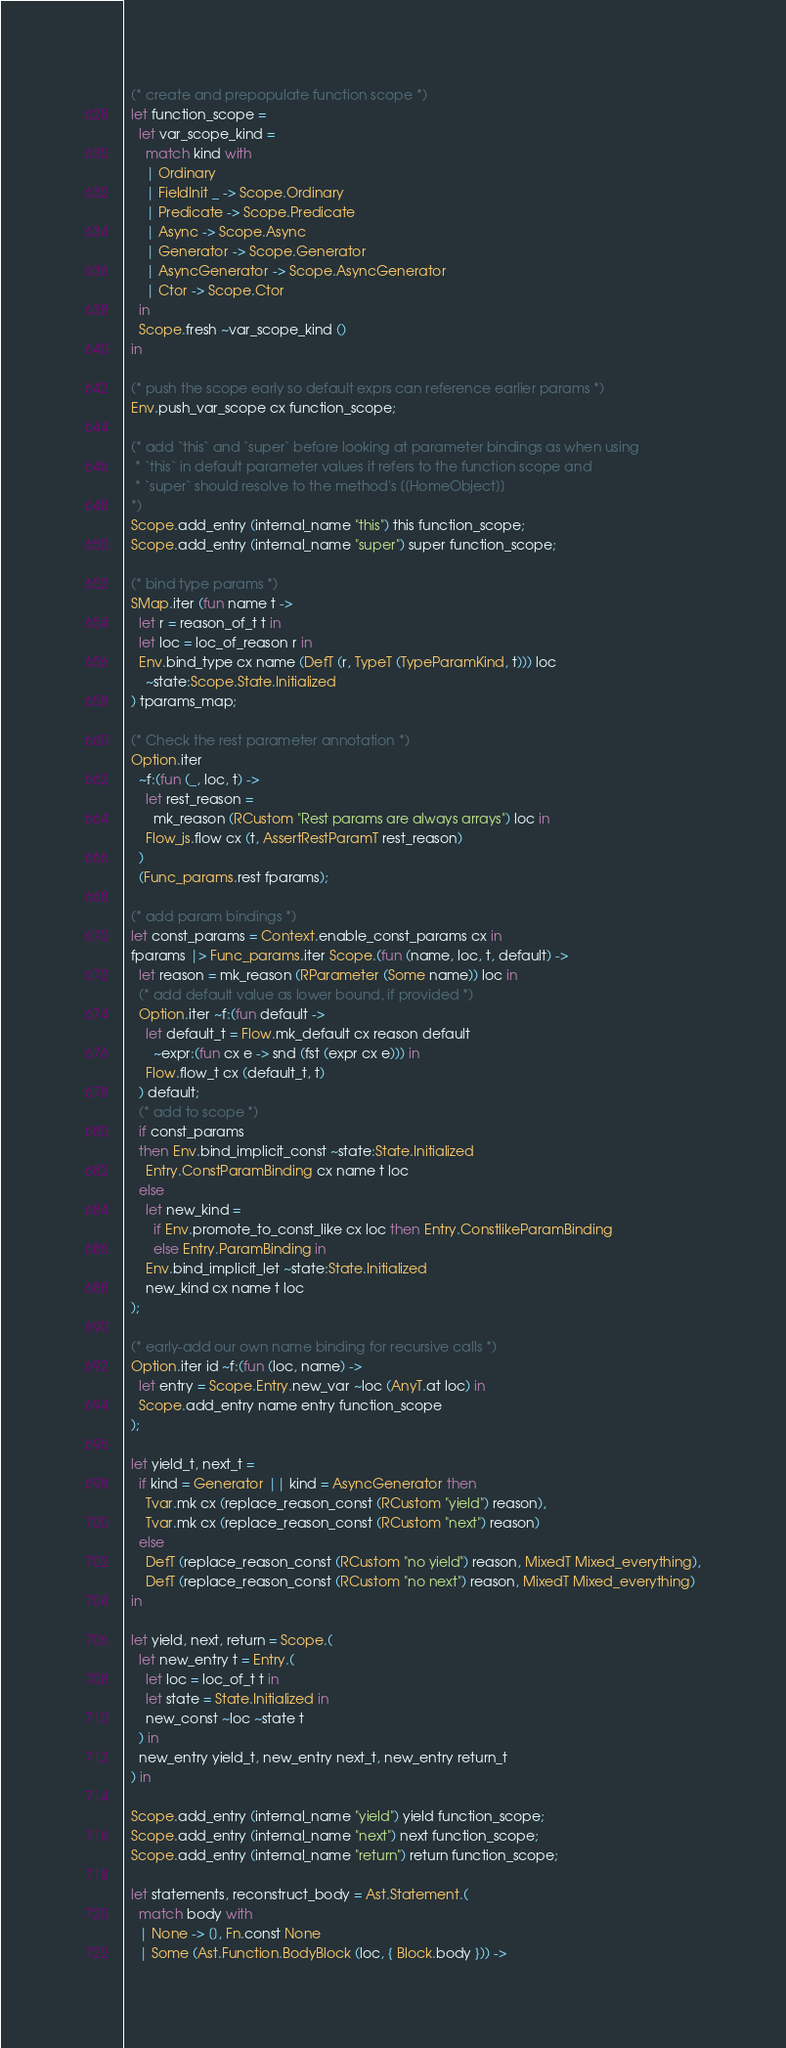<code> <loc_0><loc_0><loc_500><loc_500><_OCaml_>  (* create and prepopulate function scope *)
  let function_scope =
    let var_scope_kind =
      match kind with
      | Ordinary
      | FieldInit _ -> Scope.Ordinary
      | Predicate -> Scope.Predicate
      | Async -> Scope.Async
      | Generator -> Scope.Generator
      | AsyncGenerator -> Scope.AsyncGenerator
      | Ctor -> Scope.Ctor
    in
    Scope.fresh ~var_scope_kind ()
  in

  (* push the scope early so default exprs can reference earlier params *)
  Env.push_var_scope cx function_scope;

  (* add `this` and `super` before looking at parameter bindings as when using
   * `this` in default parameter values it refers to the function scope and
   * `super` should resolve to the method's [[HomeObject]]
  *)
  Scope.add_entry (internal_name "this") this function_scope;
  Scope.add_entry (internal_name "super") super function_scope;

  (* bind type params *)
  SMap.iter (fun name t ->
    let r = reason_of_t t in
    let loc = loc_of_reason r in
    Env.bind_type cx name (DefT (r, TypeT (TypeParamKind, t))) loc
      ~state:Scope.State.Initialized
  ) tparams_map;

  (* Check the rest parameter annotation *)
  Option.iter
    ~f:(fun (_, loc, t) ->
      let rest_reason =
        mk_reason (RCustom "Rest params are always arrays") loc in
      Flow_js.flow cx (t, AssertRestParamT rest_reason)
    )
    (Func_params.rest fparams);

  (* add param bindings *)
  let const_params = Context.enable_const_params cx in
  fparams |> Func_params.iter Scope.(fun (name, loc, t, default) ->
    let reason = mk_reason (RParameter (Some name)) loc in
    (* add default value as lower bound, if provided *)
    Option.iter ~f:(fun default ->
      let default_t = Flow.mk_default cx reason default
        ~expr:(fun cx e -> snd (fst (expr cx e))) in
      Flow.flow_t cx (default_t, t)
    ) default;
    (* add to scope *)
    if const_params
    then Env.bind_implicit_const ~state:State.Initialized
      Entry.ConstParamBinding cx name t loc
    else
      let new_kind =
        if Env.promote_to_const_like cx loc then Entry.ConstlikeParamBinding
        else Entry.ParamBinding in
      Env.bind_implicit_let ~state:State.Initialized
      new_kind cx name t loc
  );

  (* early-add our own name binding for recursive calls *)
  Option.iter id ~f:(fun (loc, name) ->
    let entry = Scope.Entry.new_var ~loc (AnyT.at loc) in
    Scope.add_entry name entry function_scope
  );

  let yield_t, next_t =
    if kind = Generator || kind = AsyncGenerator then
      Tvar.mk cx (replace_reason_const (RCustom "yield") reason),
      Tvar.mk cx (replace_reason_const (RCustom "next") reason)
    else
      DefT (replace_reason_const (RCustom "no yield") reason, MixedT Mixed_everything),
      DefT (replace_reason_const (RCustom "no next") reason, MixedT Mixed_everything)
  in

  let yield, next, return = Scope.(
    let new_entry t = Entry.(
      let loc = loc_of_t t in
      let state = State.Initialized in
      new_const ~loc ~state t
    ) in
    new_entry yield_t, new_entry next_t, new_entry return_t
  ) in

  Scope.add_entry (internal_name "yield") yield function_scope;
  Scope.add_entry (internal_name "next") next function_scope;
  Scope.add_entry (internal_name "return") return function_scope;

  let statements, reconstruct_body = Ast.Statement.(
    match body with
    | None -> [], Fn.const None
    | Some (Ast.Function.BodyBlock (loc, { Block.body })) -></code> 